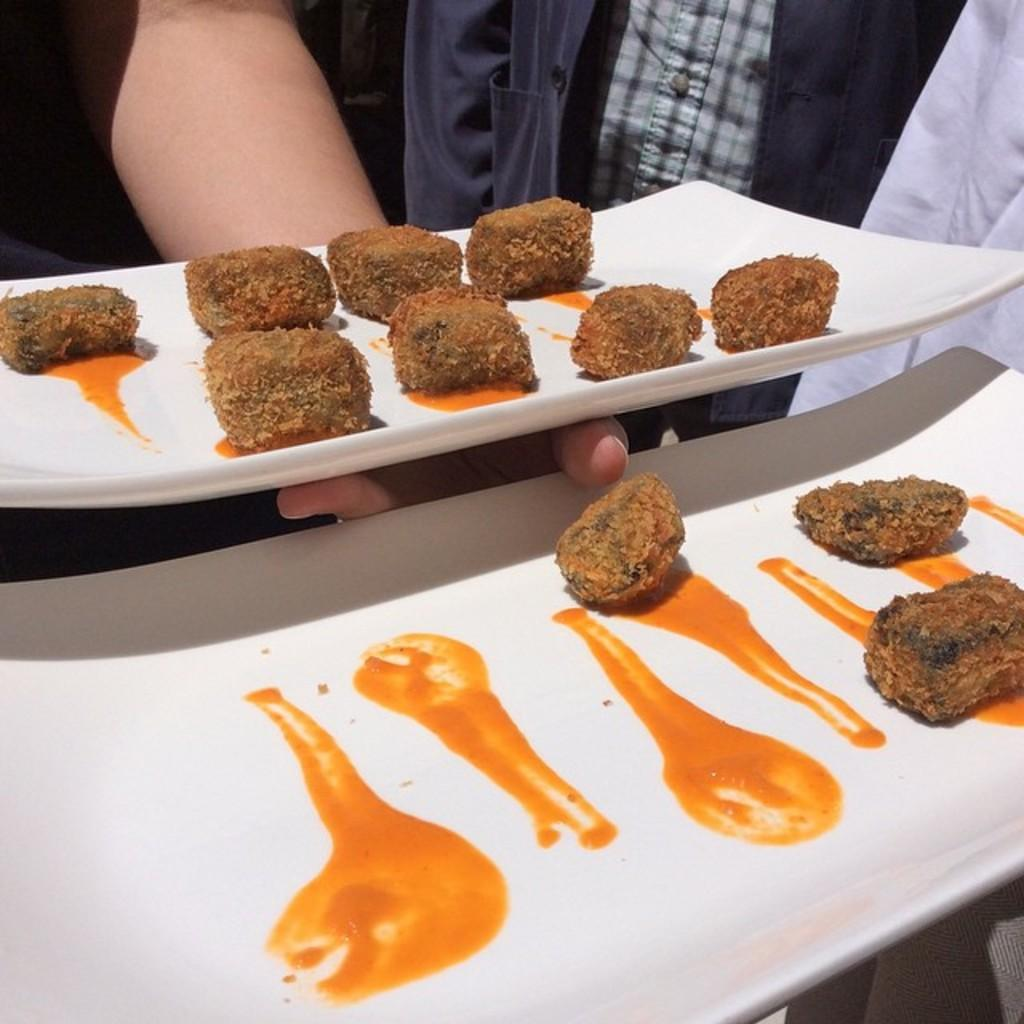Who or what is present in the image? There are people in the image. What are the people holding in the image? The people are holding white plates in the image. What is on the plates that the people are holding? There are brown food balls and sauces on the plates. What type of line can be seen connecting the food balls on the plates? There is no line connecting the food balls on the plates in the image. 